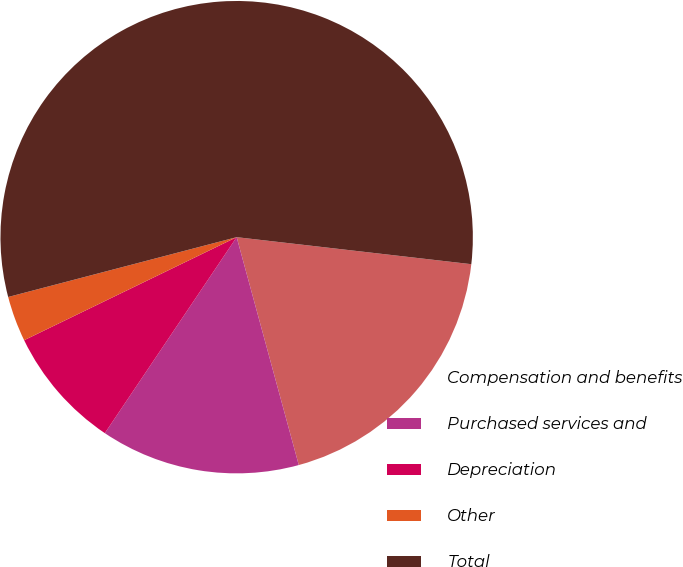Convert chart. <chart><loc_0><loc_0><loc_500><loc_500><pie_chart><fcel>Compensation and benefits<fcel>Purchased services and<fcel>Depreciation<fcel>Other<fcel>Total<nl><fcel>18.94%<fcel>13.66%<fcel>8.39%<fcel>3.11%<fcel>55.9%<nl></chart> 